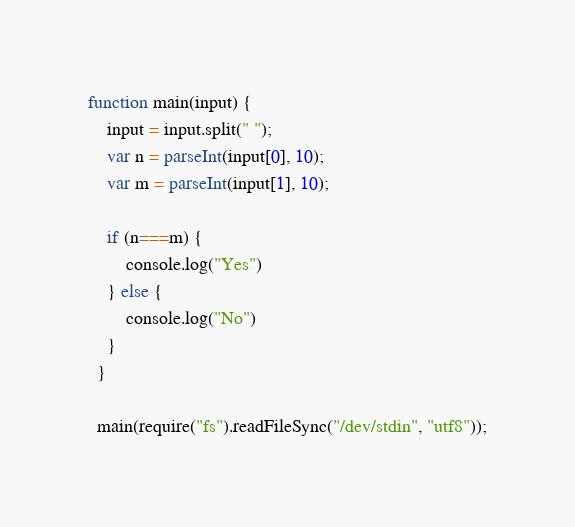<code> <loc_0><loc_0><loc_500><loc_500><_JavaScript_>function main(input) {
    input = input.split(" ");
    var n = parseInt(input[0], 10);
    var m = parseInt(input[1], 10);

    if (n===m) {
        console.log("Yes")
    } else {
        console.log("No")
    }
  }
   
  main(require("fs").readFileSync("/dev/stdin", "utf8"));

</code> 